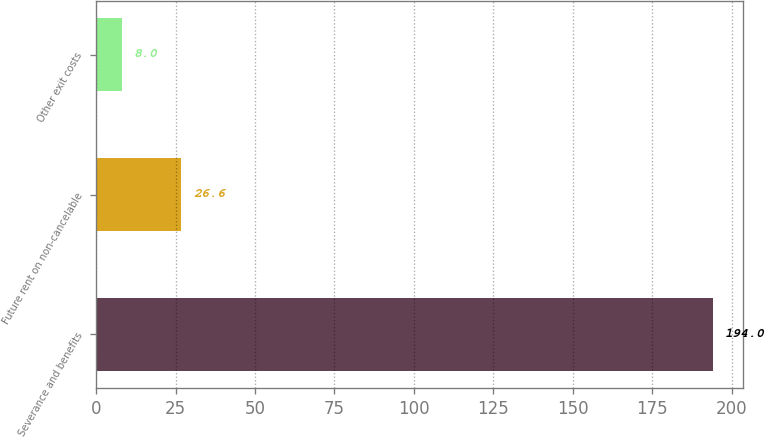Convert chart. <chart><loc_0><loc_0><loc_500><loc_500><bar_chart><fcel>Severance and benefits<fcel>Future rent on non-cancelable<fcel>Other exit costs<nl><fcel>194<fcel>26.6<fcel>8<nl></chart> 